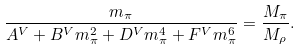Convert formula to latex. <formula><loc_0><loc_0><loc_500><loc_500>\frac { m _ { \pi } } { A ^ { V } + B ^ { V } m _ { \pi } ^ { 2 } + D ^ { V } m _ { \pi } ^ { 4 } + F ^ { V } m _ { \pi } ^ { 6 } } = \frac { M _ { \pi } } { M _ { \rho } } .</formula> 